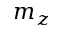<formula> <loc_0><loc_0><loc_500><loc_500>m _ { z }</formula> 